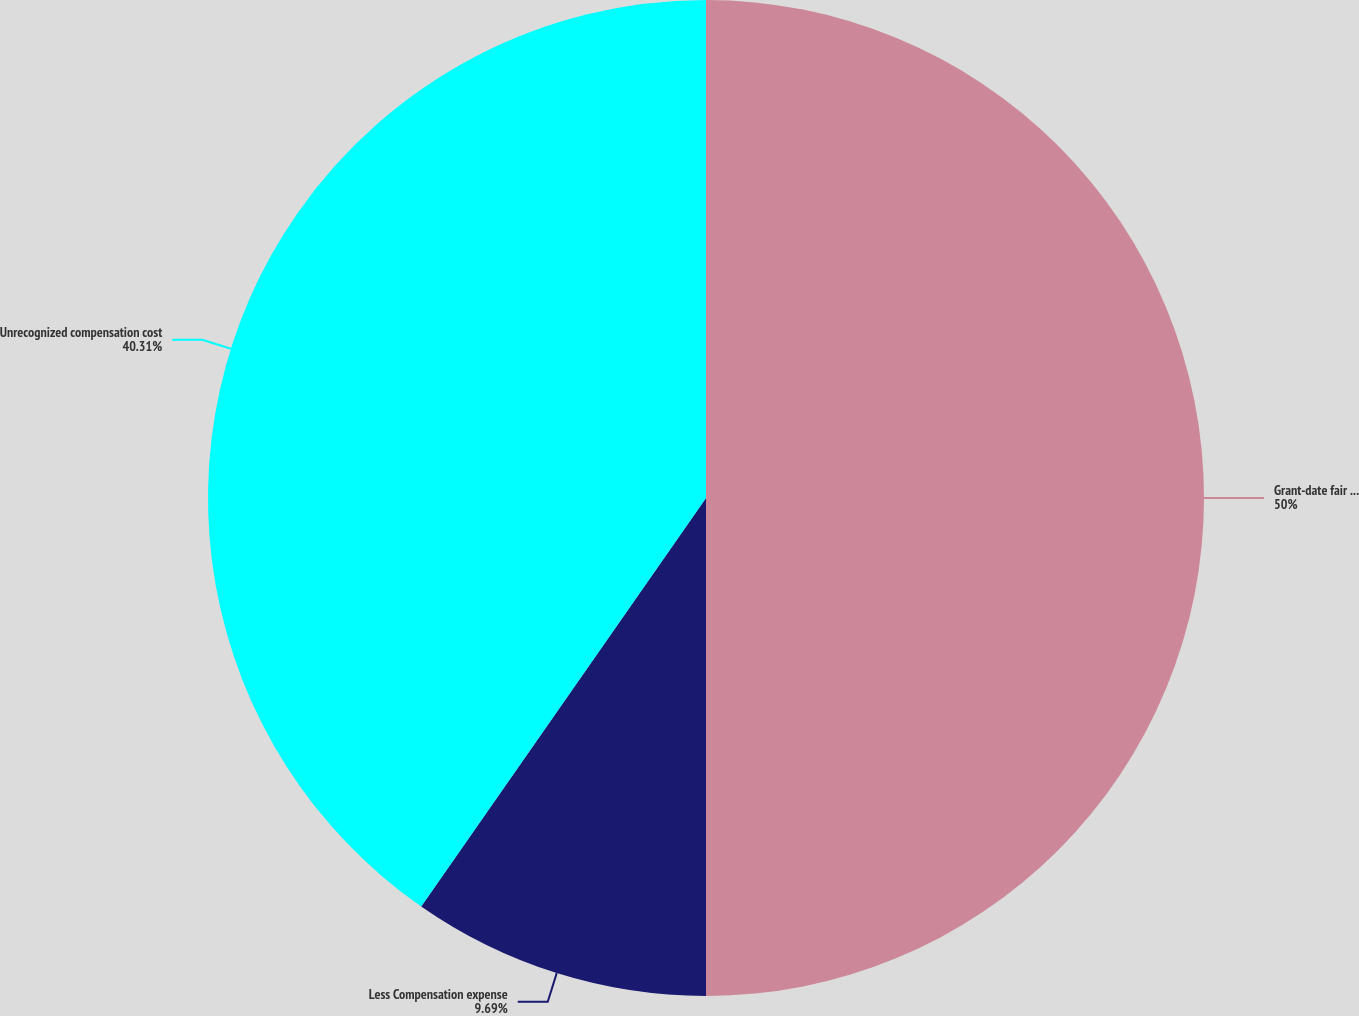Convert chart to OTSL. <chart><loc_0><loc_0><loc_500><loc_500><pie_chart><fcel>Grant-date fair value<fcel>Less Compensation expense<fcel>Unrecognized compensation cost<nl><fcel>50.0%<fcel>9.69%<fcel>40.31%<nl></chart> 